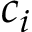<formula> <loc_0><loc_0><loc_500><loc_500>c _ { i }</formula> 